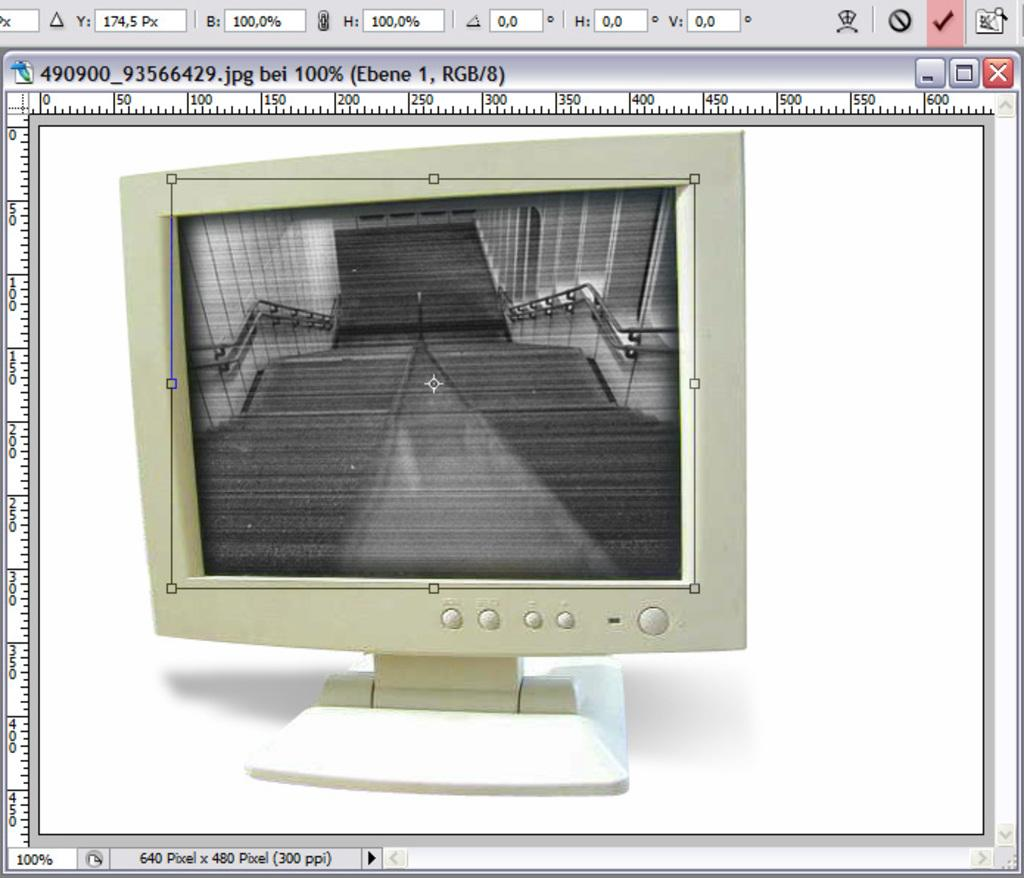<image>
Create a compact narrative representing the image presented. An image of a CRT computer monitor that is 640 by 480 pixels and named 490900_93566429.jpg 